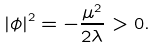Convert formula to latex. <formula><loc_0><loc_0><loc_500><loc_500>\left | \phi \right | ^ { 2 } = - \frac { \mu ^ { 2 } } { 2 \lambda } > 0 .</formula> 